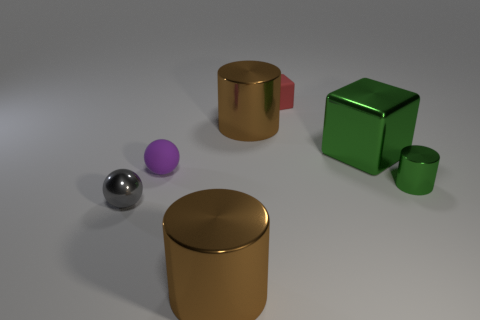Do the large brown cylinder that is in front of the gray thing and the tiny purple object have the same material?
Offer a very short reply. No. What is the material of the large brown thing in front of the large green shiny object?
Offer a terse response. Metal. What is the size of the sphere that is behind the tiny green cylinder behind the tiny gray ball?
Your answer should be compact. Small. What number of brown shiny cylinders have the same size as the red rubber object?
Provide a short and direct response. 0. There is a rubber object behind the matte ball; is its color the same as the block to the right of the red matte cube?
Your answer should be very brief. No. There is a tiny green cylinder; are there any brown metal objects behind it?
Keep it short and to the point. Yes. There is a small object that is in front of the rubber ball and on the right side of the small metallic ball; what color is it?
Provide a short and direct response. Green. Are there any large shiny objects of the same color as the metal block?
Make the answer very short. No. Is the material of the purple object in front of the matte block the same as the large brown cylinder behind the gray metal sphere?
Offer a very short reply. No. What size is the ball that is on the left side of the purple ball?
Your answer should be very brief. Small. 